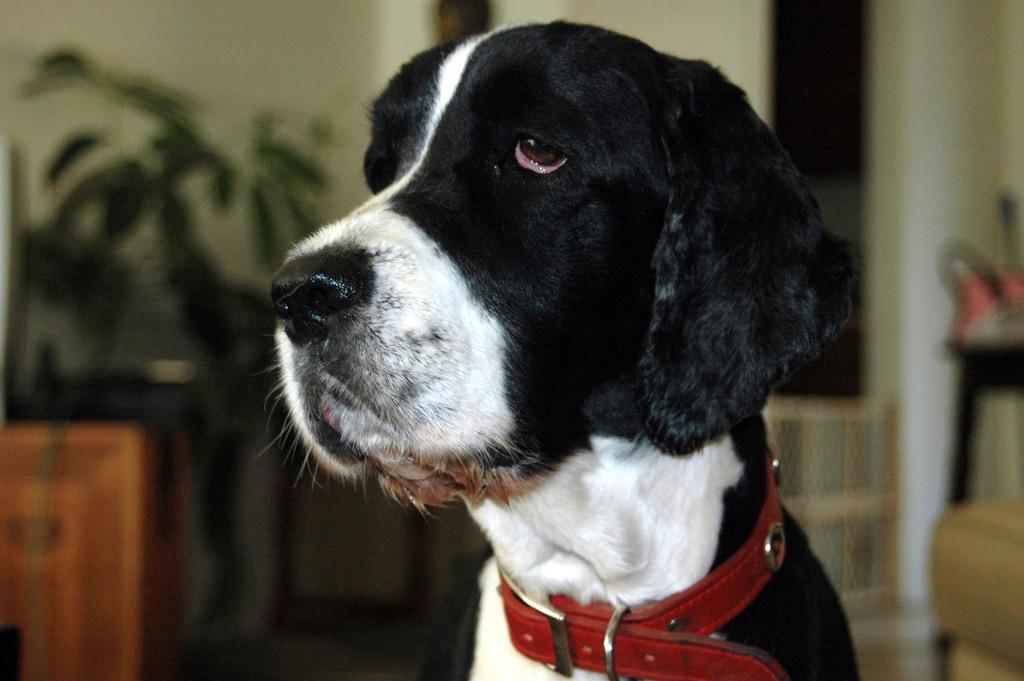How would you summarize this image in a sentence or two? In this image we can see a dog, there are some potted plants on the table, also we can see some other objects, in the background we can see the wall. 